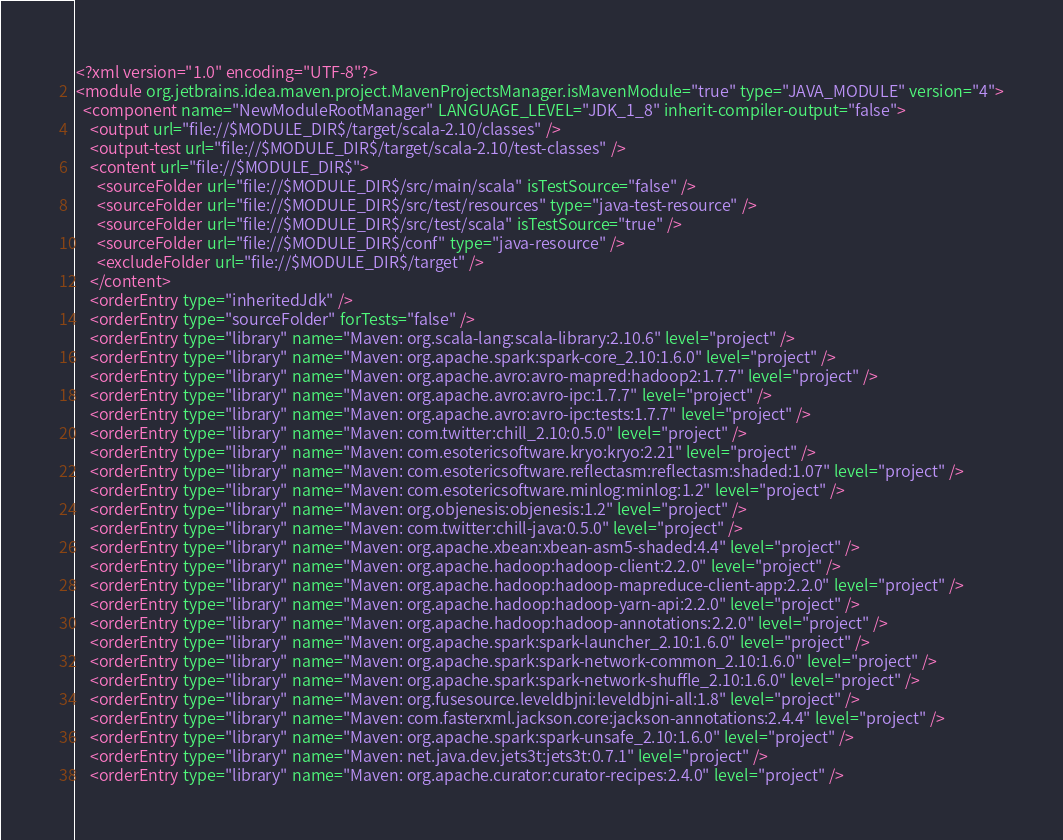<code> <loc_0><loc_0><loc_500><loc_500><_XML_><?xml version="1.0" encoding="UTF-8"?>
<module org.jetbrains.idea.maven.project.MavenProjectsManager.isMavenModule="true" type="JAVA_MODULE" version="4">
  <component name="NewModuleRootManager" LANGUAGE_LEVEL="JDK_1_8" inherit-compiler-output="false">
    <output url="file://$MODULE_DIR$/target/scala-2.10/classes" />
    <output-test url="file://$MODULE_DIR$/target/scala-2.10/test-classes" />
    <content url="file://$MODULE_DIR$">
      <sourceFolder url="file://$MODULE_DIR$/src/main/scala" isTestSource="false" />
      <sourceFolder url="file://$MODULE_DIR$/src/test/resources" type="java-test-resource" />
      <sourceFolder url="file://$MODULE_DIR$/src/test/scala" isTestSource="true" />
      <sourceFolder url="file://$MODULE_DIR$/conf" type="java-resource" />
      <excludeFolder url="file://$MODULE_DIR$/target" />
    </content>
    <orderEntry type="inheritedJdk" />
    <orderEntry type="sourceFolder" forTests="false" />
    <orderEntry type="library" name="Maven: org.scala-lang:scala-library:2.10.6" level="project" />
    <orderEntry type="library" name="Maven: org.apache.spark:spark-core_2.10:1.6.0" level="project" />
    <orderEntry type="library" name="Maven: org.apache.avro:avro-mapred:hadoop2:1.7.7" level="project" />
    <orderEntry type="library" name="Maven: org.apache.avro:avro-ipc:1.7.7" level="project" />
    <orderEntry type="library" name="Maven: org.apache.avro:avro-ipc:tests:1.7.7" level="project" />
    <orderEntry type="library" name="Maven: com.twitter:chill_2.10:0.5.0" level="project" />
    <orderEntry type="library" name="Maven: com.esotericsoftware.kryo:kryo:2.21" level="project" />
    <orderEntry type="library" name="Maven: com.esotericsoftware.reflectasm:reflectasm:shaded:1.07" level="project" />
    <orderEntry type="library" name="Maven: com.esotericsoftware.minlog:minlog:1.2" level="project" />
    <orderEntry type="library" name="Maven: org.objenesis:objenesis:1.2" level="project" />
    <orderEntry type="library" name="Maven: com.twitter:chill-java:0.5.0" level="project" />
    <orderEntry type="library" name="Maven: org.apache.xbean:xbean-asm5-shaded:4.4" level="project" />
    <orderEntry type="library" name="Maven: org.apache.hadoop:hadoop-client:2.2.0" level="project" />
    <orderEntry type="library" name="Maven: org.apache.hadoop:hadoop-mapreduce-client-app:2.2.0" level="project" />
    <orderEntry type="library" name="Maven: org.apache.hadoop:hadoop-yarn-api:2.2.0" level="project" />
    <orderEntry type="library" name="Maven: org.apache.hadoop:hadoop-annotations:2.2.0" level="project" />
    <orderEntry type="library" name="Maven: org.apache.spark:spark-launcher_2.10:1.6.0" level="project" />
    <orderEntry type="library" name="Maven: org.apache.spark:spark-network-common_2.10:1.6.0" level="project" />
    <orderEntry type="library" name="Maven: org.apache.spark:spark-network-shuffle_2.10:1.6.0" level="project" />
    <orderEntry type="library" name="Maven: org.fusesource.leveldbjni:leveldbjni-all:1.8" level="project" />
    <orderEntry type="library" name="Maven: com.fasterxml.jackson.core:jackson-annotations:2.4.4" level="project" />
    <orderEntry type="library" name="Maven: org.apache.spark:spark-unsafe_2.10:1.6.0" level="project" />
    <orderEntry type="library" name="Maven: net.java.dev.jets3t:jets3t:0.7.1" level="project" />
    <orderEntry type="library" name="Maven: org.apache.curator:curator-recipes:2.4.0" level="project" /></code> 